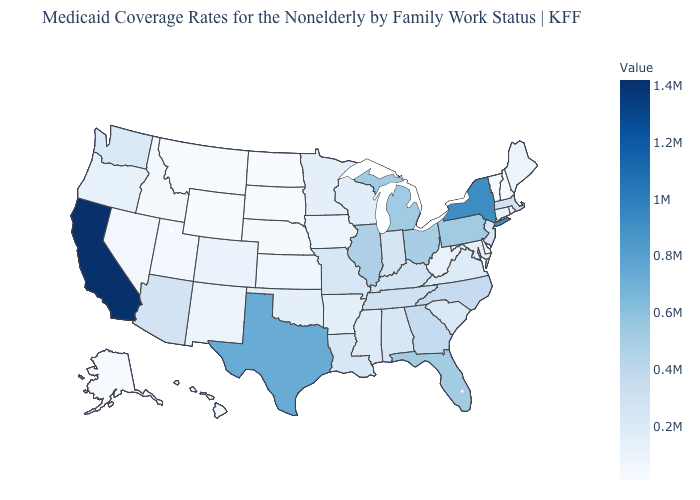Among the states that border South Carolina , does North Carolina have the highest value?
Write a very short answer. No. Among the states that border Texas , does Louisiana have the highest value?
Keep it brief. Yes. Among the states that border Alabama , does Tennessee have the highest value?
Be succinct. No. 